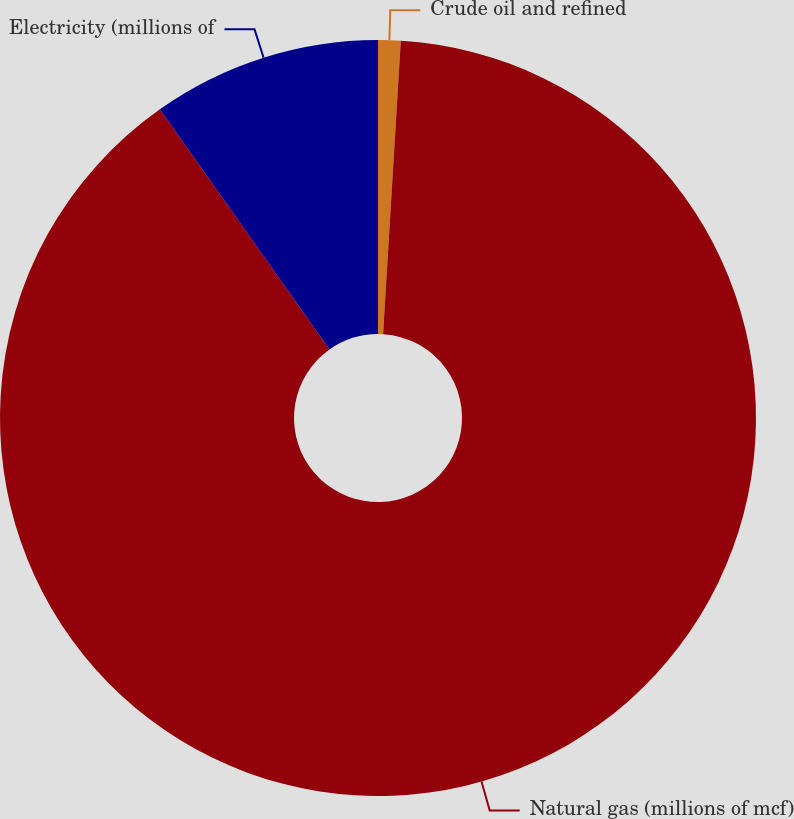Convert chart. <chart><loc_0><loc_0><loc_500><loc_500><pie_chart><fcel>Crude oil and refined<fcel>Natural gas (millions of mcf)<fcel>Electricity (millions of<nl><fcel>0.96%<fcel>89.26%<fcel>9.79%<nl></chart> 